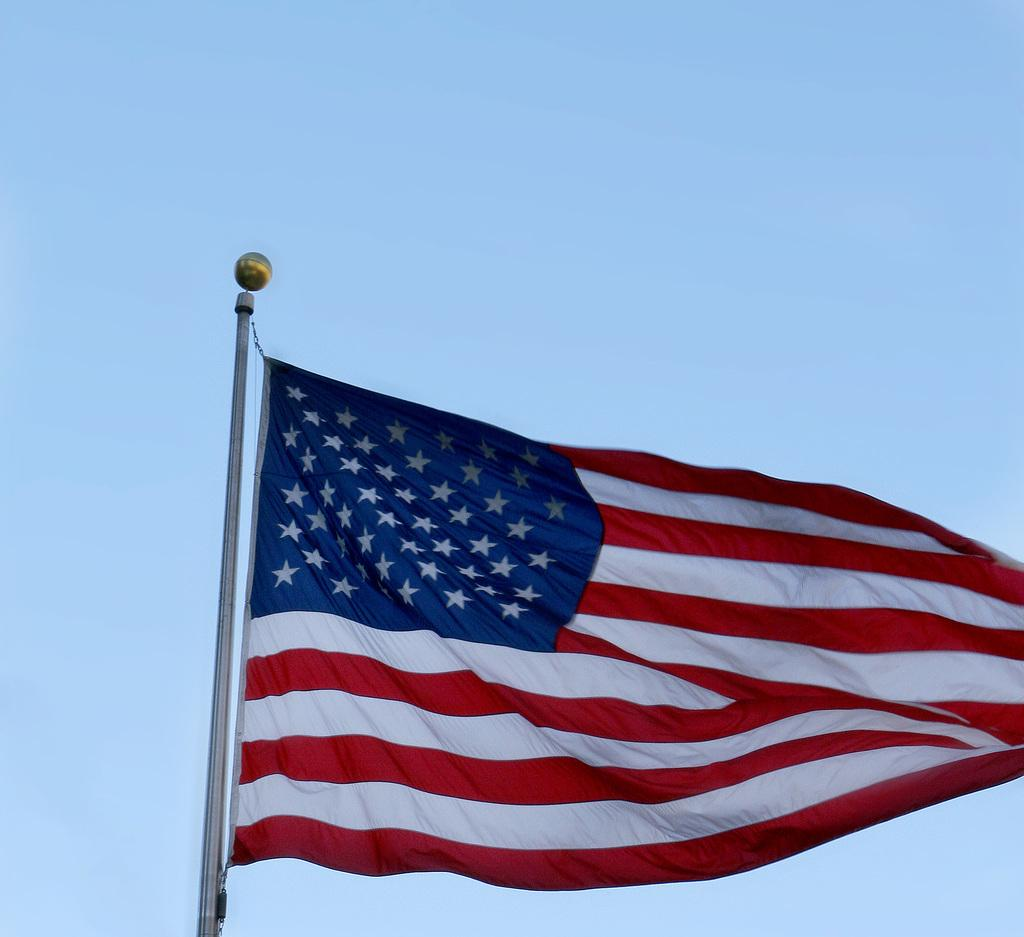What is on the pole in the image? There is a flag and an object on the pole in the image. What can be seen in the background of the image? The sky is visible in the background of the image. How many girls are standing in line to receive their orders for beans in the image? There are no girls or beans present in the image. 